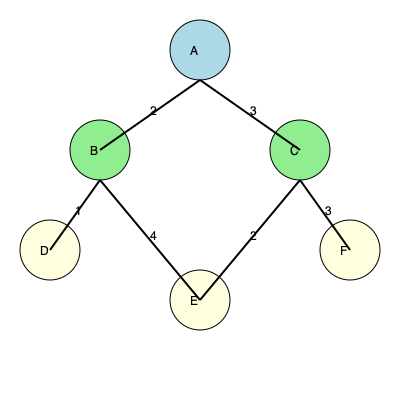You want to plan a neighborhood walk that starts and ends at your house (node A) and covers all the local parks (nodes B through F). What is the minimum total distance for a route that visits all parks exactly once before returning home, assuming the numbers on the edges represent distances in kilometers? To solve this problem, we need to find the shortest Hamiltonian cycle in the graph, which is known as the Traveling Salesman Problem (TSP). Here's a step-by-step approach:

1) First, list all possible routes that start and end at A and visit all other nodes exactly once:

   ABCDEF, ABCEDF, ABCFED, ABDEFC, ABDFEC, ABECDF, ABEDFC, ABEFCD, ABFCED, ABFEDC

2) Calculate the total distance for each route:

   ABCDEF: 2 + 3 + 2 + 4 + 3 + 2 = 16
   ABCEDF: 2 + 3 + 2 + 4 + 1 + 2 = 14
   ABCFED: 2 + 3 + 3 + 2 + 4 + 2 = 16
   ABDEFC: 2 + 1 + 4 + 2 + 3 + 3 = 15
   ABDFEC: 2 + 1 + 3 + 3 + 2 + 3 = 14
   ABECDF: 2 + 4 + 2 + 3 + 1 + 2 = 14
   ABEDFC: 2 + 4 + 2 + 1 + 3 + 3 = 15
   ABEFCD: 2 + 4 + 3 + 3 + 3 + 2 = 17
   ABFCED: 2 + 4 + 3 + 3 + 2 + 2 = 16
   ABFEDC: 2 + 4 + 3 + 2 + 4 + 2 = 17

3) Identify the routes with the minimum total distance:

   ABCEDF, ABDFEC, and ABECDF all have a total distance of 14 km.

Therefore, the minimum total distance for a route that visits all parks exactly once before returning home is 14 km.
Answer: 14 km 